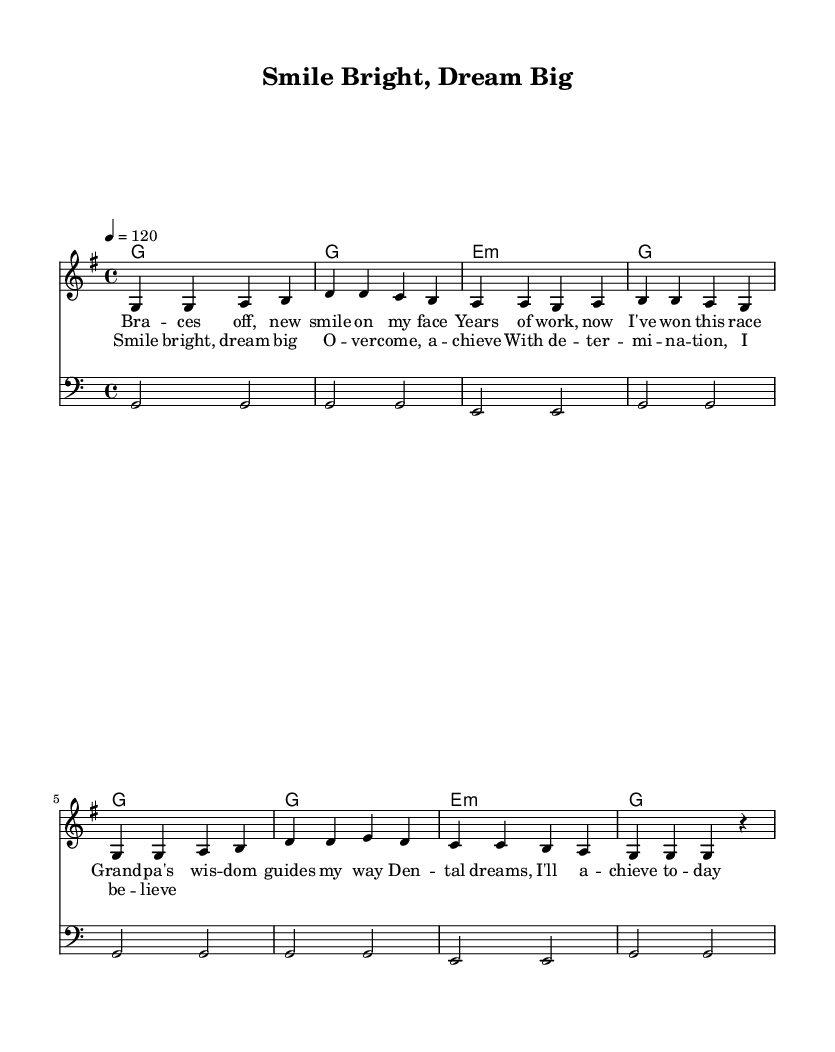What is the key signature of this music? The key signature is G major, which has one sharp (F#). This can be identified by looking at the key signature notation at the beginning of the stave.
Answer: G major What is the time signature of the piece? The time signature is 4/4, which means there are four beats in each measure and the quarter note gets one beat. This is indicated at the beginning where the time signature is placed.
Answer: 4/4 What is the tempo marking of the song? The tempo is marked at 120 beats per minute, which is indicated in the tempo directive showing '4 = 120' at the beginning of the score. This tells the musician how fast to play the piece.
Answer: 120 How many measures are in the melody? There are eight measures in the melody. Counting the bar lines from the start to the end provides the number of measures present.
Answer: Eight What is the overall mood conveyed by the lyrics? The lyrics convey an optimistic and motivational mood, reflected in phrases such as "Smile bright" and "dream big." The positive language suggests a theme of overcoming obstacles.
Answer: Optimistic Which chord appears most frequently in the harmonies? The chord G major appears most frequently in the harmonies; it is indicated multiple times in the chord progression throughout the piece.
Answer: G major What aspect of the lyrics speaks to your personal journey? The lyrics mention "new smile on my face" and "dental dreams," directly relating to personal experiences and aspirations in the field of dentistry, creating a connection between the song and an individual’s journey.
Answer: Dental dreams 